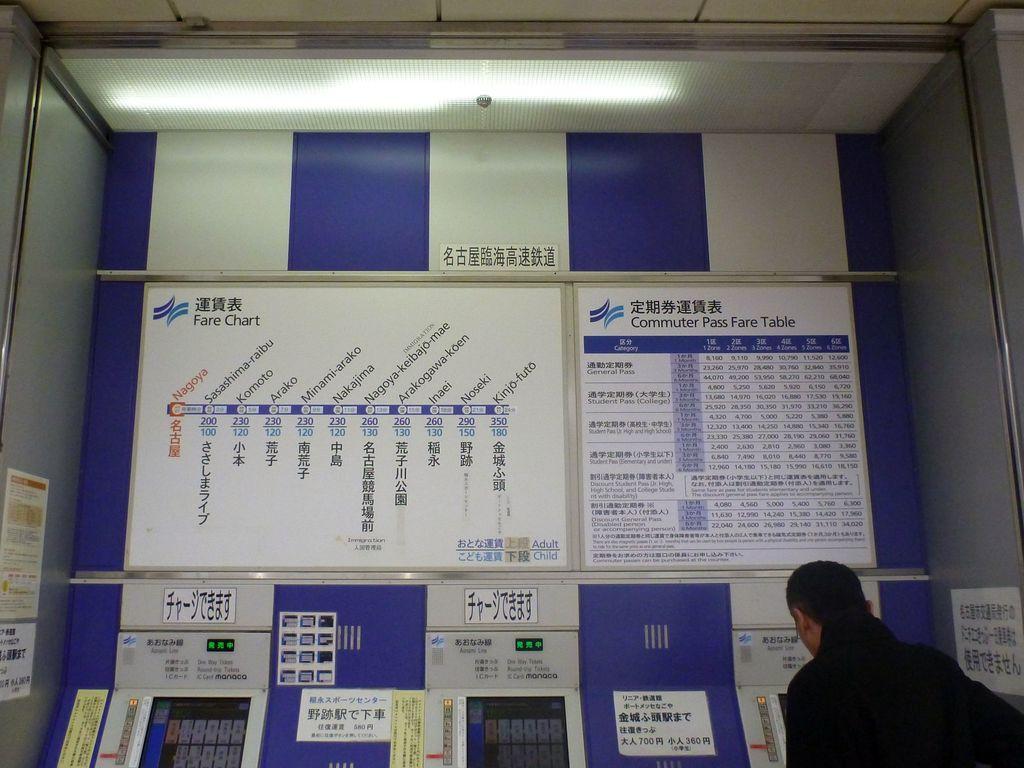What kind of chart is this?
Keep it short and to the point. Fare. What type of table is on the right?
Provide a succinct answer. Commuter pass fare table. 